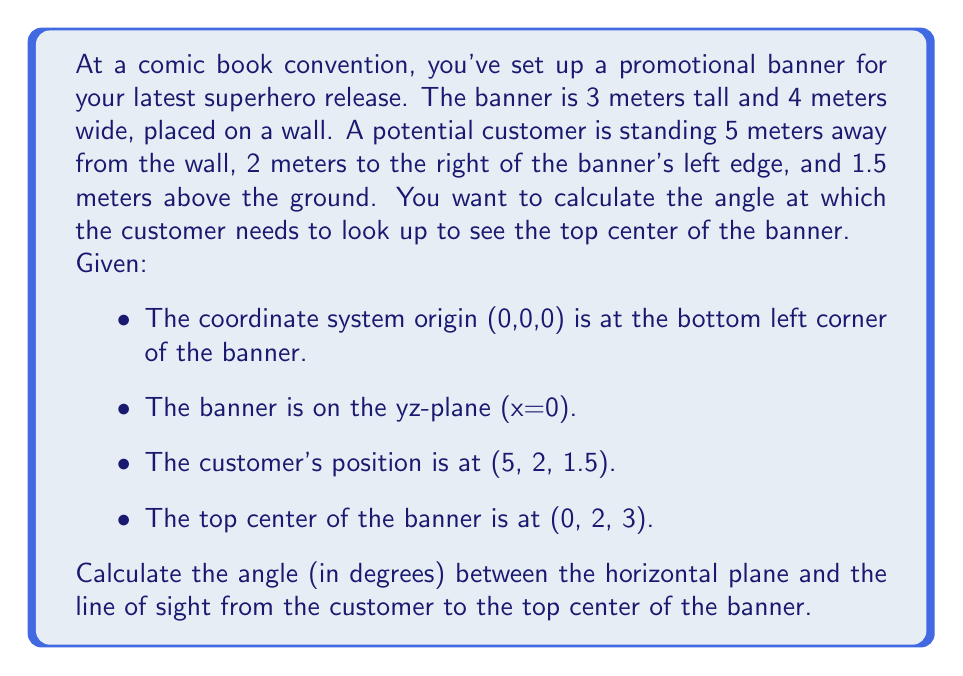Help me with this question. To solve this problem, we'll use vector operations and trigonometry. Let's break it down step by step:

1) First, let's define our vectors:
   - Customer position: $\vec{C} = (5, 2, 1.5)$
   - Top center of banner: $\vec{B} = (0, 2, 3)$

2) Calculate the vector from the customer to the banner top center:
   $\vec{V} = \vec{B} - \vec{C} = (0-5, 2-2, 3-1.5) = (-5, 0, 1.5)$

3) The angle we're looking for is between this vector and its projection on the horizontal (xy) plane. The projection is simply $\vec{V_{xy}} = (-5, 0, 0)$.

4) To find the angle, we can use the dot product formula:
   $$\cos \theta = \frac{\vec{V} \cdot \vec{V_{xy}}}{|\vec{V}||\vec{V_{xy}}|}$$

5) Calculate the magnitudes:
   $|\vec{V}| = \sqrt{(-5)^2 + 0^2 + 1.5^2} = \sqrt{25 + 2.25} = \sqrt{27.25} \approx 5.22$
   $|\vec{V_{xy}}| = 5$

6) Calculate the dot product:
   $\vec{V} \cdot \vec{V_{xy}} = (-5)(-5) + 0(0) + 1.5(0) = 25$

7) Substitute into the formula:
   $$\cos \theta = \frac{25}{5.22 * 5} \approx 0.9578$$

8) Take the inverse cosine (arccos) and convert to degrees:
   $$\theta = \arccos(0.9578) * \frac{180}{\pi} \approx 16.70°$$
Answer: The angle between the horizontal plane and the line of sight from the customer to the top center of the banner is approximately 16.70°. 